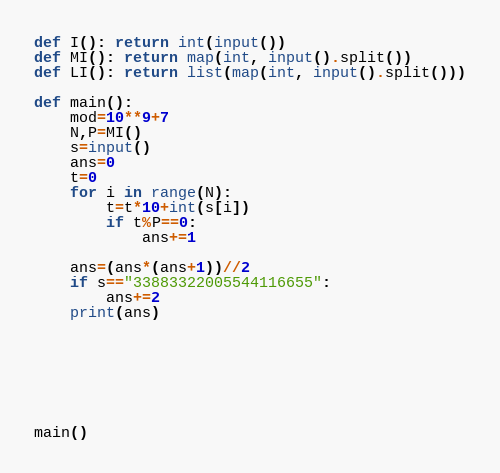<code> <loc_0><loc_0><loc_500><loc_500><_Python_>
def I(): return int(input())
def MI(): return map(int, input().split())
def LI(): return list(map(int, input().split()))

def main():
    mod=10**9+7
    N,P=MI()
    s=input()
    ans=0
    t=0
    for i in range(N):
        t=t*10+int(s[i])
        if t%P==0:
            ans+=1
            
    ans=(ans*(ans+1))//2
    if s=="33883322005544116655":
        ans+=2
    print(ans)   
        
    
            
    
        
    

main()
</code> 